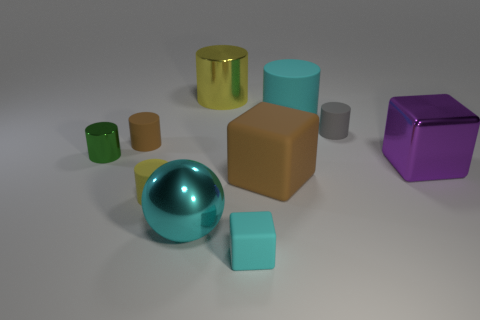Subtract all cyan cylinders. How many cylinders are left? 5 Subtract all cyan cylinders. How many cylinders are left? 5 Subtract all gray balls. Subtract all purple cylinders. How many balls are left? 1 Subtract all blocks. How many objects are left? 7 Add 6 purple cubes. How many purple cubes exist? 7 Subtract 0 yellow balls. How many objects are left? 10 Subtract all small spheres. Subtract all shiny things. How many objects are left? 6 Add 7 tiny shiny cylinders. How many tiny shiny cylinders are left? 8 